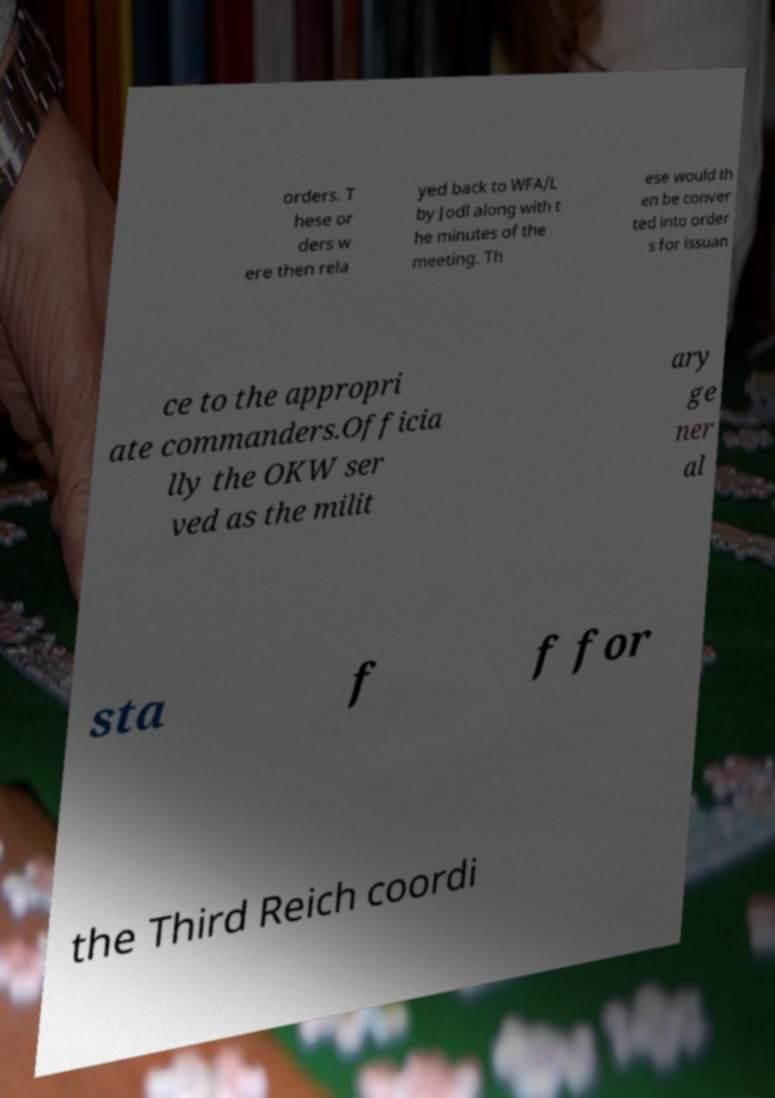Please identify and transcribe the text found in this image. orders. T hese or ders w ere then rela yed back to WFA/L by Jodl along with t he minutes of the meeting. Th ese would th en be conver ted into order s for issuan ce to the appropri ate commanders.Officia lly the OKW ser ved as the milit ary ge ner al sta f f for the Third Reich coordi 